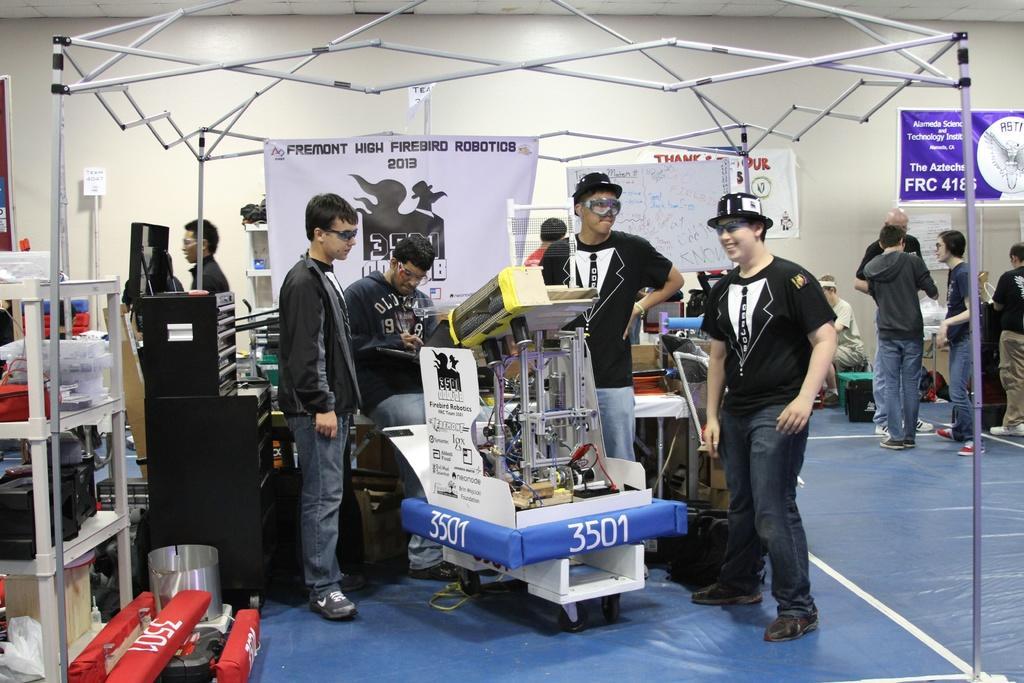In one or two sentences, can you explain what this image depicts? In this image I can see there are few persons visible and I can see a rack on the left side and in the rack I can see boxes and papers, at the top I can see iron fence , three is a board attached to the fence and I can see a machine visible in the foreground ,back side of fence I can see the wall , on the wall I can see banner attached and some papers visible on the right side. 